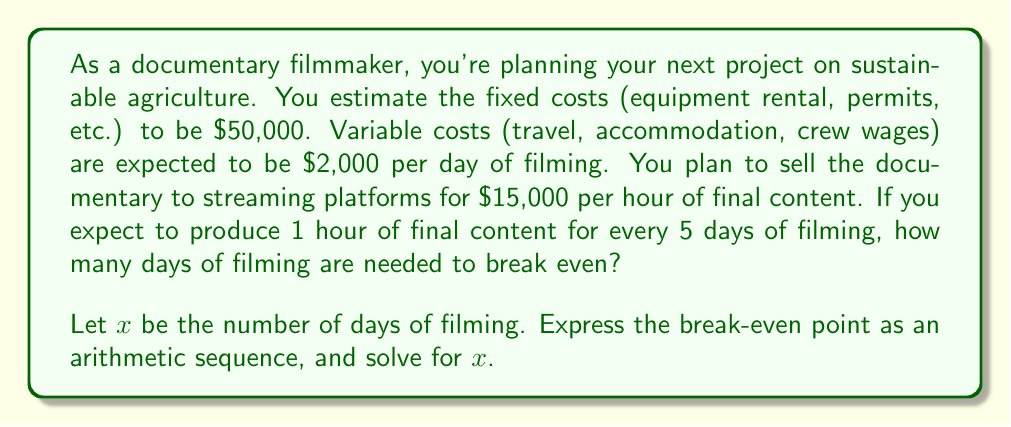Can you answer this question? To solve this problem, we need to set up an equation where the revenue equals the total costs (fixed + variable). Let's break it down step-by-step:

1. Fixed costs: $50,000
2. Variable costs: $2,000 per day
3. Revenue: $15,000 per hour of final content, where 1 hour is produced every 5 days of filming

Let $x$ be the number of days of filming.

Revenue function:
$$R(x) = 15000 \cdot \frac{x}{5}$$

Total cost function:
$$C(x) = 50000 + 2000x$$

At the break-even point, revenue equals total cost:
$$R(x) = C(x)$$

$$15000 \cdot \frac{x}{5} = 50000 + 2000x$$

Simplify the left side:
$$3000x = 50000 + 2000x$$

Subtract 2000x from both sides:
$$1000x = 50000$$

Divide both sides by 1000:
$$x = 50$$

Therefore, the break-even point occurs at 50 days of filming.

To express this as an arithmetic sequence, we can consider the daily profit/loss:

$$a_n = -50000 + (3000 - 2000)n$$

Where $n$ is the number of days and $a_n$ is the profit/loss on day $n$.

The break-even point occurs when $a_n = 0$:

$$0 = -50000 + 1000n$$
$$50000 = 1000n$$
$$n = 50$$

This confirms our previous calculation.
Answer: The break-even point occurs at 50 days of filming. 